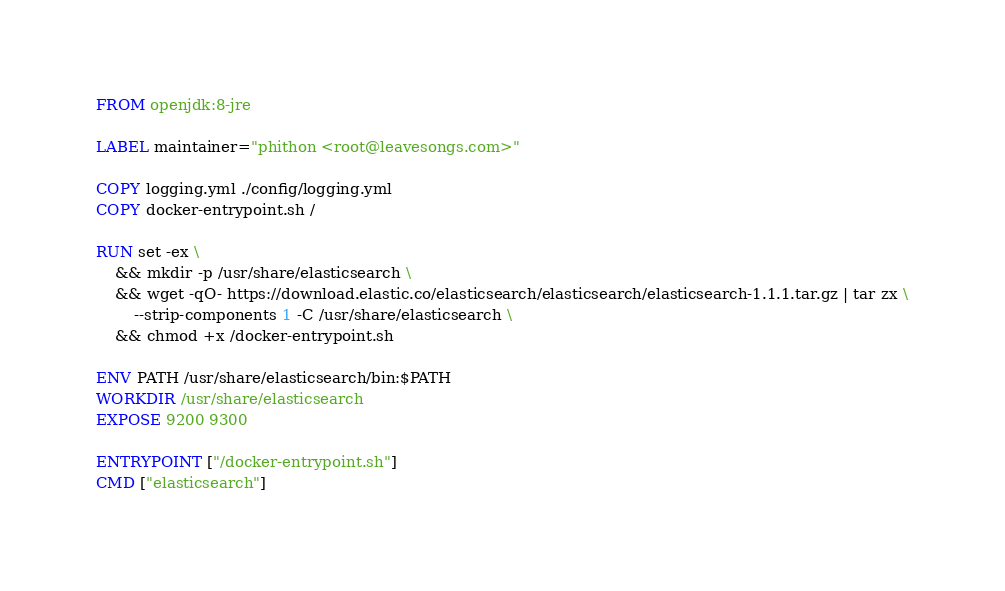<code> <loc_0><loc_0><loc_500><loc_500><_Dockerfile_>FROM openjdk:8-jre

LABEL maintainer="phithon <root@leavesongs.com>"

COPY logging.yml ./config/logging.yml
COPY docker-entrypoint.sh /

RUN set -ex \
    && mkdir -p /usr/share/elasticsearch \
    && wget -qO- https://download.elastic.co/elasticsearch/elasticsearch/elasticsearch-1.1.1.tar.gz | tar zx \
        --strip-components 1 -C /usr/share/elasticsearch \
    && chmod +x /docker-entrypoint.sh

ENV PATH /usr/share/elasticsearch/bin:$PATH
WORKDIR /usr/share/elasticsearch
EXPOSE 9200 9300

ENTRYPOINT ["/docker-entrypoint.sh"]
CMD ["elasticsearch"]</code> 